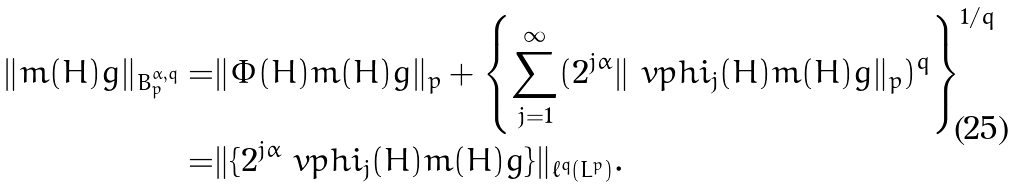<formula> <loc_0><loc_0><loc_500><loc_500>\| m ( H ) g \| _ { B _ { p } ^ { \alpha , q } } = & \| \Phi ( H ) m ( H ) g \| _ { p } + \left \{ \sum _ { j = 1 } ^ { \infty } ( 2 ^ { j \alpha } \| \ v p h i _ { j } ( H ) m ( H ) g \| _ { p } ) ^ { q } \right \} ^ { 1 / q } \\ = & \| \{ 2 ^ { j \alpha } \ v p h i _ { j } ( H ) m ( H ) g \} \| _ { \ell ^ { q } ( L ^ { p } ) } .</formula> 